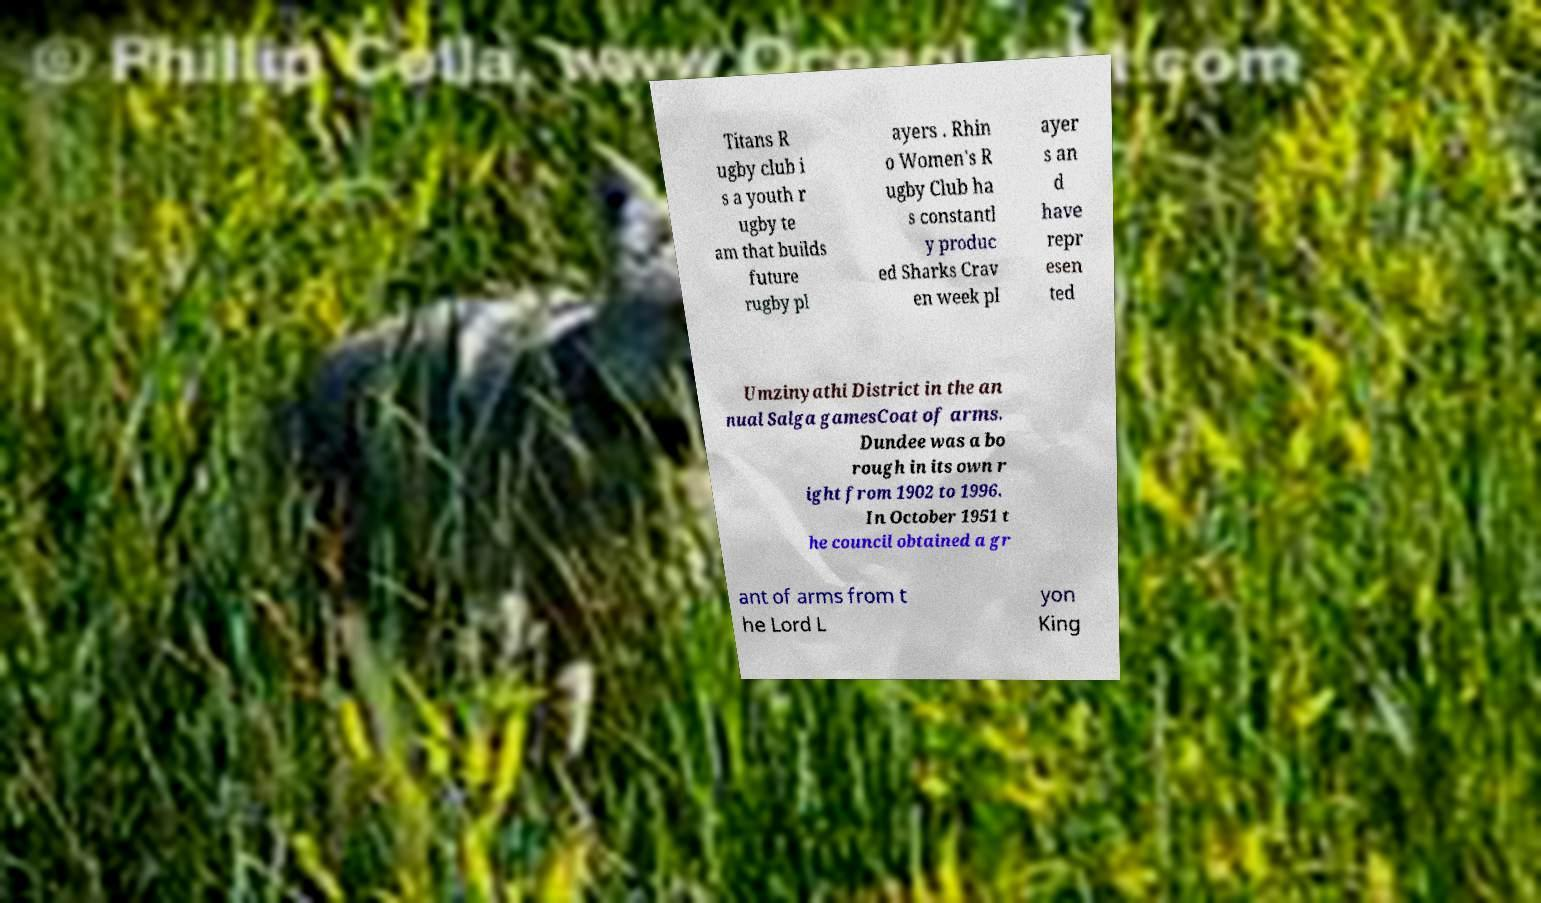Please identify and transcribe the text found in this image. Titans R ugby club i s a youth r ugby te am that builds future rugby pl ayers . Rhin o Women's R ugby Club ha s constantl y produc ed Sharks Crav en week pl ayer s an d have repr esen ted Umzinyathi District in the an nual Salga gamesCoat of arms. Dundee was a bo rough in its own r ight from 1902 to 1996. In October 1951 t he council obtained a gr ant of arms from t he Lord L yon King 